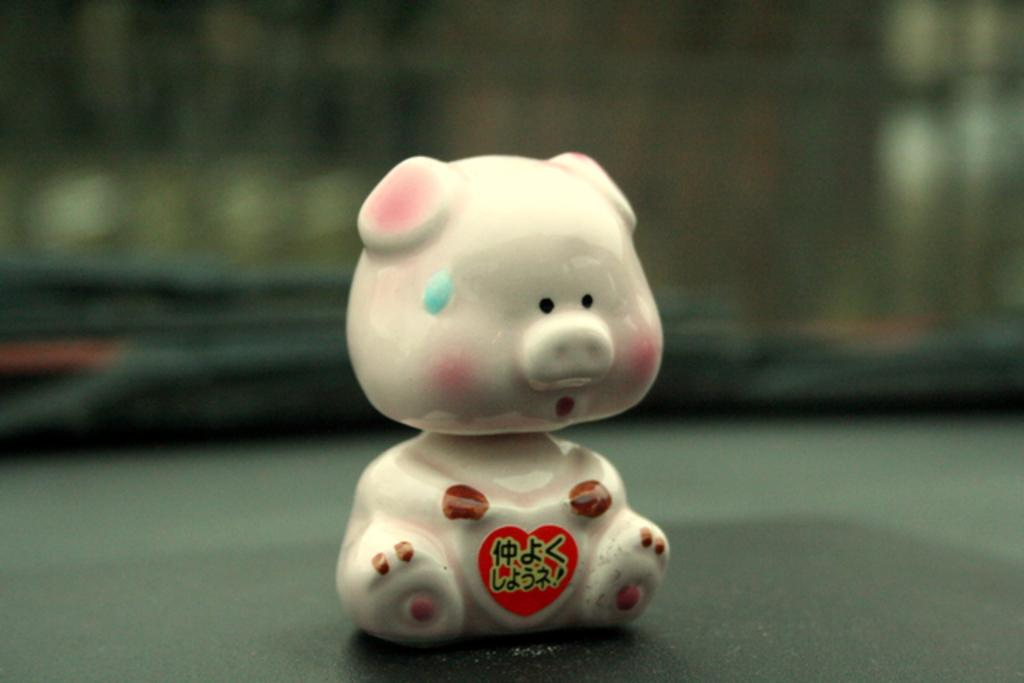What object is placed on the floor in the image? There is a toy visible on the floor. What type of horn can be seen growing from the toy in the image? There is no horn present on the toy in the image. What type of plant is growing next to the toy in the image? There is no plant present in the image. What type of pig is sitting on the toy in the image? There is no pig present in the image. 